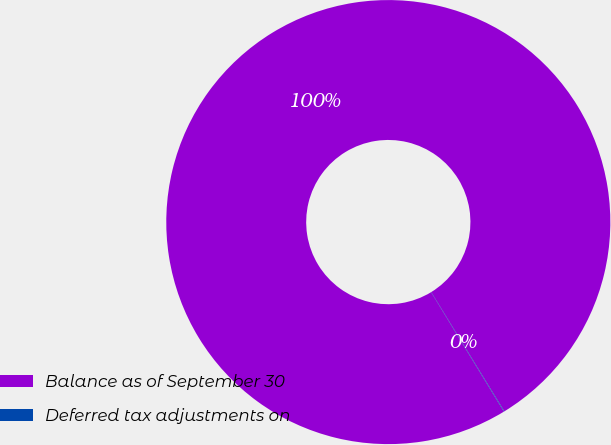Convert chart. <chart><loc_0><loc_0><loc_500><loc_500><pie_chart><fcel>Balance as of September 30<fcel>Deferred tax adjustments on<nl><fcel>99.96%<fcel>0.04%<nl></chart> 